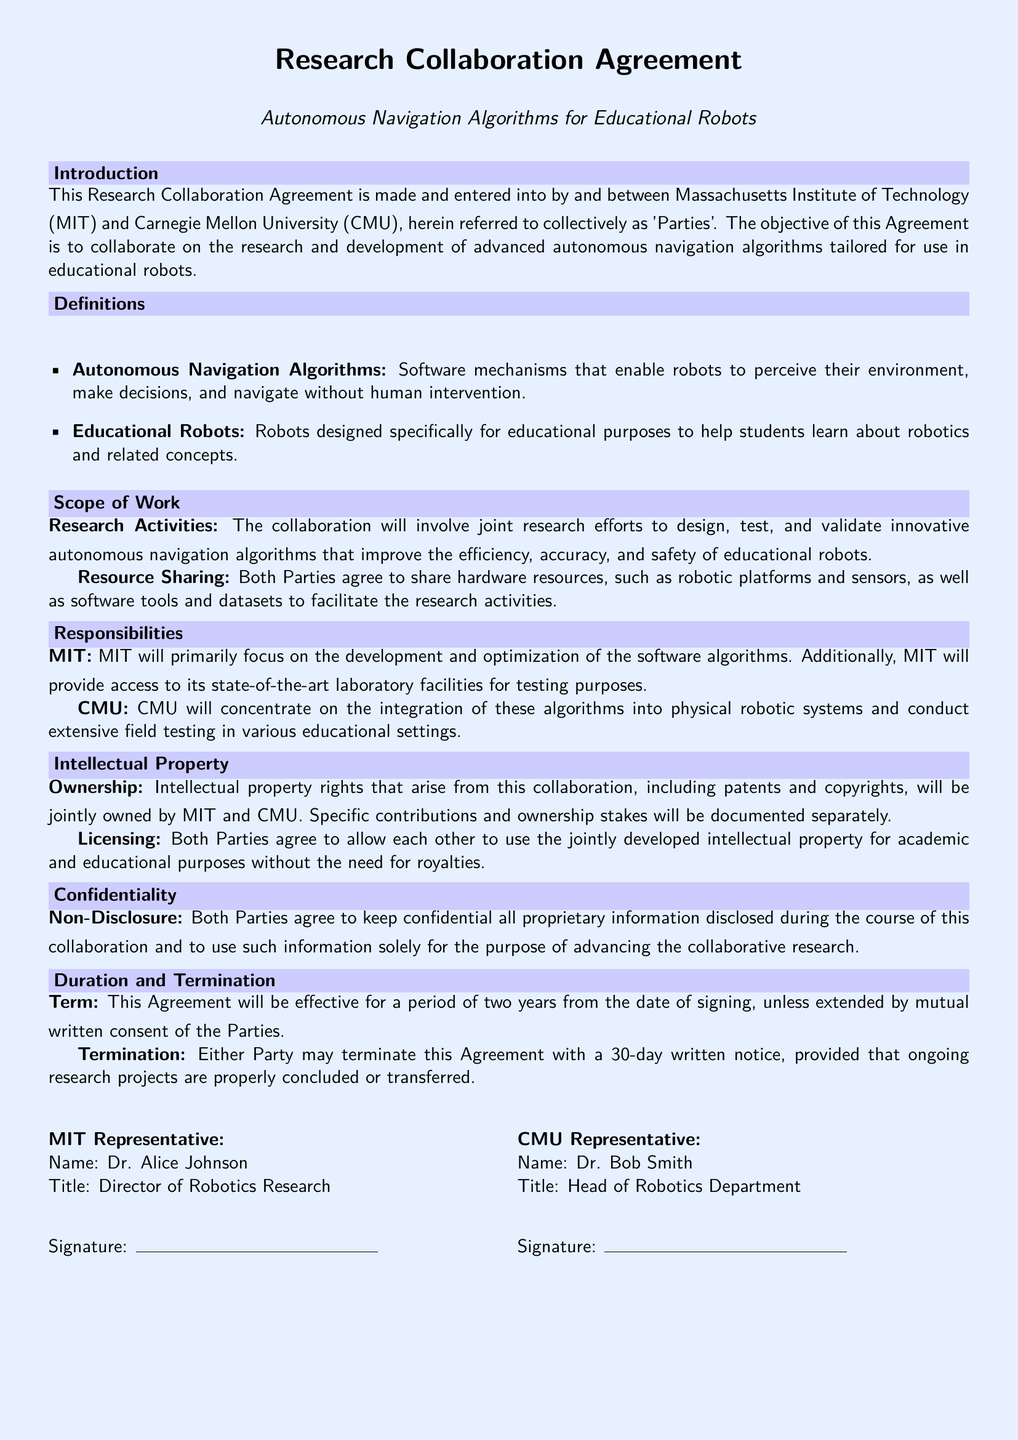What is the objective of this Agreement? The objective of this Agreement is to collaborate on the research and development of advanced autonomous navigation algorithms tailored for use in educational robots.
Answer: To collaborate on autonomous navigation algorithms Who are the parties involved in this Agreement? The parties involved are Massachusetts Institute of Technology (MIT) and Carnegie Mellon University (CMU).
Answer: MIT and CMU What are Autonomous Navigation Algorithms? Autonomous Navigation Algorithms are software mechanisms that enable robots to perceive their environment, make decisions, and navigate without human intervention.
Answer: Software mechanisms for robots What is the term of the Agreement? The Agreement is effective for a period of two years from the date of signing.
Answer: Two years Who focuses on developing software algorithms? MIT will primarily focus on the development and optimization of the software algorithms.
Answer: MIT What must both parties keep confidential? Both Parties agree to keep confidential all proprietary information disclosed during the course of this collaboration.
Answer: Proprietary information What is the ownership status of intellectual property? Intellectual property rights that arise from this collaboration will be jointly owned by MIT and CMU.
Answer: Jointly owned How long is the notice period for terminating the Agreement? Either Party may terminate this Agreement with a 30-day written notice.
Answer: 30-day written notice 